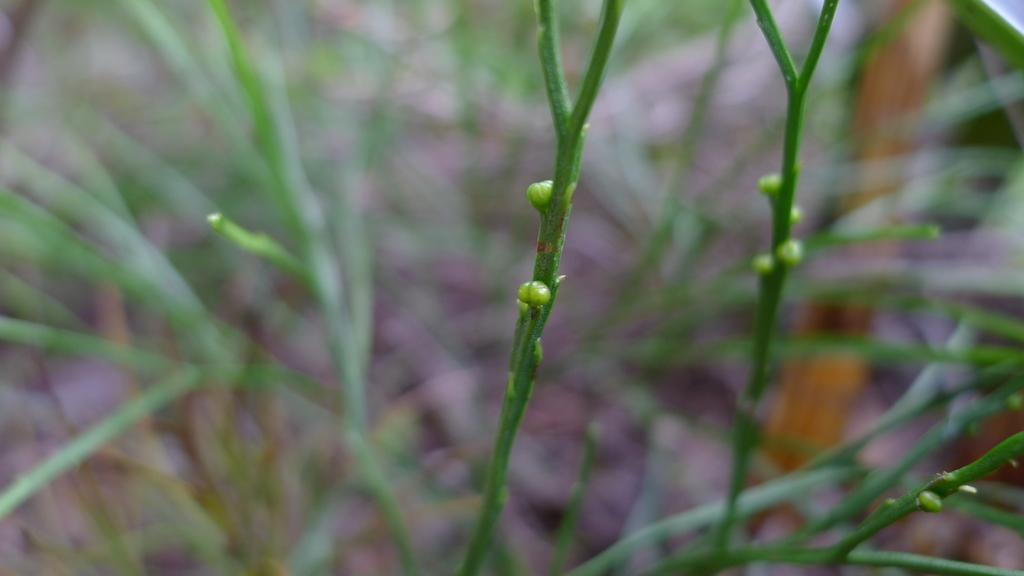What type of plant elements are visible in the image? There are buds and branches of a plant in the image. Can you describe the stage of growth of the plant elements? The presence of buds suggests that the plant is in the process of growth. What type of wine is being served on the sofa in the image? There is no wine or sofa present in the image; it features buds and branches of a plant. 